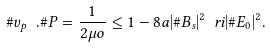Convert formula to latex. <formula><loc_0><loc_0><loc_500><loc_500>\# v _ { p } \ . \# P = \frac { 1 } { 2 \mu o } \leq 1 - 8 a | \# B _ { s } | ^ { 2 } \ r i | \# E _ { 0 } | ^ { 2 } .</formula> 